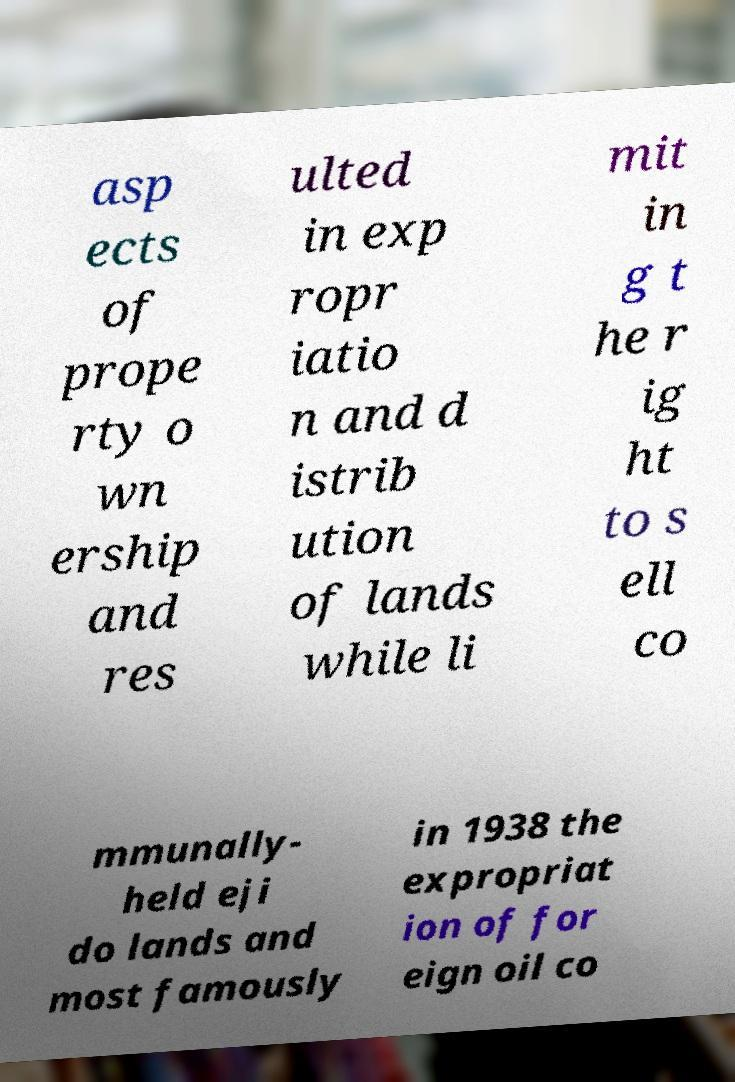For documentation purposes, I need the text within this image transcribed. Could you provide that? asp ects of prope rty o wn ership and res ulted in exp ropr iatio n and d istrib ution of lands while li mit in g t he r ig ht to s ell co mmunally- held eji do lands and most famously in 1938 the expropriat ion of for eign oil co 